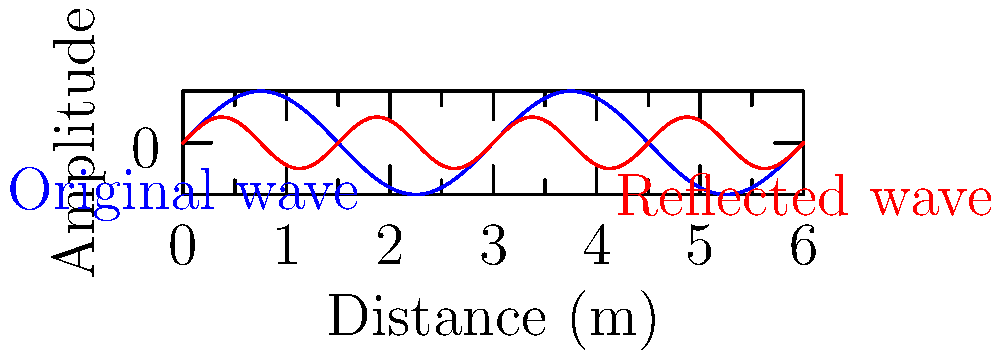In an underground crypt, a sound wave travels 3 meters before hitting a stone wall and reflecting back. If the original wave (blue) has a frequency of 440 Hz and the reflected wave (red) experiences a 50% reduction in amplitude, what is the wavelength of the reflected wave? To solve this problem, let's follow these steps:

1. The speed of sound in air at room temperature is approximately 343 m/s.

2. We can use the wave equation to find the wavelength:
   $v = f \lambda$
   Where $v$ is the speed of sound, $f$ is the frequency, and $\lambda$ is the wavelength.

3. Rearranging the equation to solve for $\lambda$:
   $\lambda = \frac{v}{f}$

4. Substituting the values:
   $\lambda = \frac{343 \text{ m/s}}{440 \text{ Hz}} = 0.78 \text{ m}$

5. The reflection doesn't change the frequency or wavelength of the wave, only its amplitude. The wavelength of the reflected wave remains the same as the original wave.

6. The 50% reduction in amplitude is shown in the graph, where the red wave (reflected) has half the amplitude of the blue wave (original).
Answer: 0.78 m 